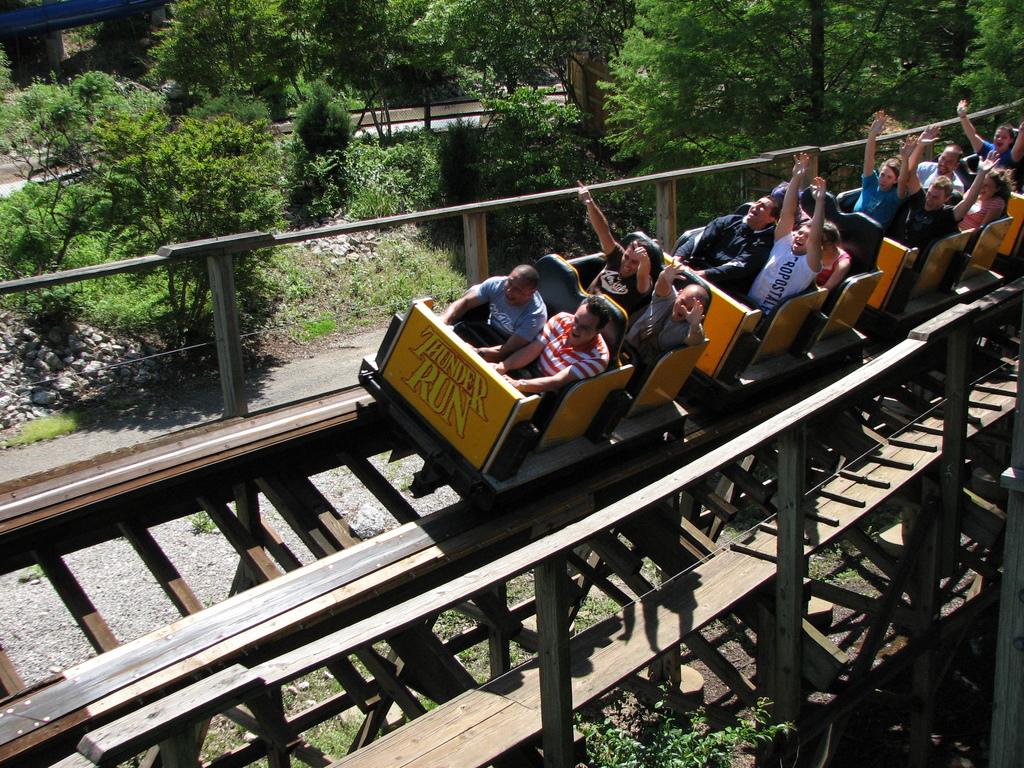What is this ride called?
Offer a terse response. Thunder run. What brand is the white tshirt?
Ensure brevity in your answer.  Aeropostale. 